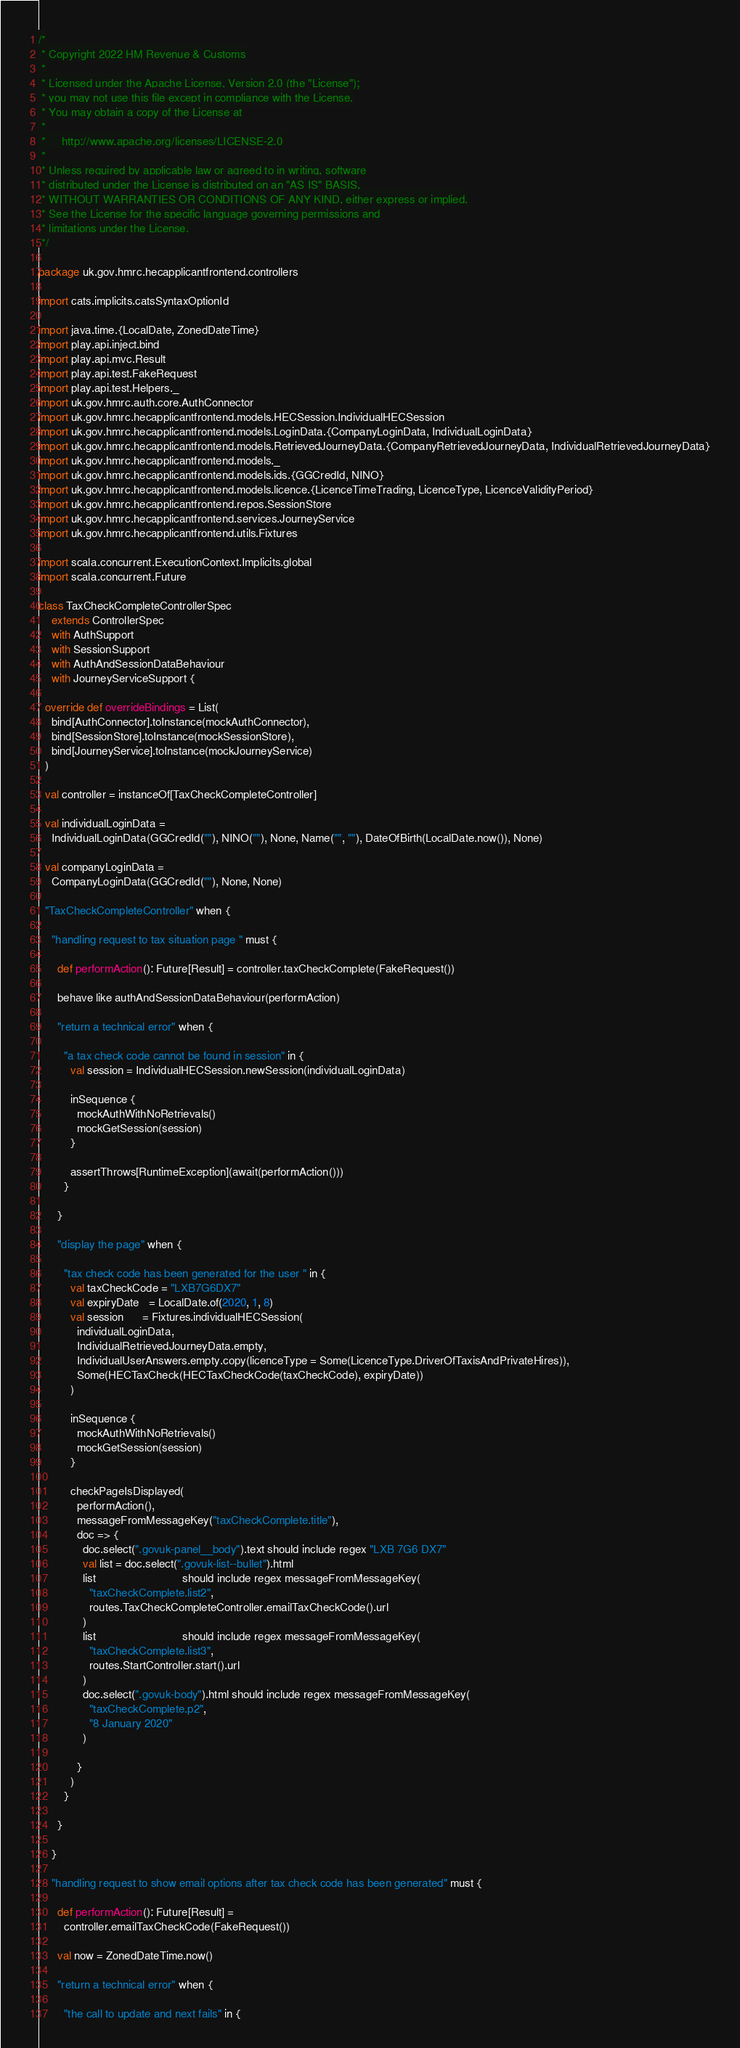<code> <loc_0><loc_0><loc_500><loc_500><_Scala_>/*
 * Copyright 2022 HM Revenue & Customs
 *
 * Licensed under the Apache License, Version 2.0 (the "License");
 * you may not use this file except in compliance with the License.
 * You may obtain a copy of the License at
 *
 *     http://www.apache.org/licenses/LICENSE-2.0
 *
 * Unless required by applicable law or agreed to in writing, software
 * distributed under the License is distributed on an "AS IS" BASIS,
 * WITHOUT WARRANTIES OR CONDITIONS OF ANY KIND, either express or implied.
 * See the License for the specific language governing permissions and
 * limitations under the License.
 */

package uk.gov.hmrc.hecapplicantfrontend.controllers

import cats.implicits.catsSyntaxOptionId

import java.time.{LocalDate, ZonedDateTime}
import play.api.inject.bind
import play.api.mvc.Result
import play.api.test.FakeRequest
import play.api.test.Helpers._
import uk.gov.hmrc.auth.core.AuthConnector
import uk.gov.hmrc.hecapplicantfrontend.models.HECSession.IndividualHECSession
import uk.gov.hmrc.hecapplicantfrontend.models.LoginData.{CompanyLoginData, IndividualLoginData}
import uk.gov.hmrc.hecapplicantfrontend.models.RetrievedJourneyData.{CompanyRetrievedJourneyData, IndividualRetrievedJourneyData}
import uk.gov.hmrc.hecapplicantfrontend.models._
import uk.gov.hmrc.hecapplicantfrontend.models.ids.{GGCredId, NINO}
import uk.gov.hmrc.hecapplicantfrontend.models.licence.{LicenceTimeTrading, LicenceType, LicenceValidityPeriod}
import uk.gov.hmrc.hecapplicantfrontend.repos.SessionStore
import uk.gov.hmrc.hecapplicantfrontend.services.JourneyService
import uk.gov.hmrc.hecapplicantfrontend.utils.Fixtures

import scala.concurrent.ExecutionContext.Implicits.global
import scala.concurrent.Future

class TaxCheckCompleteControllerSpec
    extends ControllerSpec
    with AuthSupport
    with SessionSupport
    with AuthAndSessionDataBehaviour
    with JourneyServiceSupport {

  override def overrideBindings = List(
    bind[AuthConnector].toInstance(mockAuthConnector),
    bind[SessionStore].toInstance(mockSessionStore),
    bind[JourneyService].toInstance(mockJourneyService)
  )

  val controller = instanceOf[TaxCheckCompleteController]

  val individualLoginData =
    IndividualLoginData(GGCredId(""), NINO(""), None, Name("", ""), DateOfBirth(LocalDate.now()), None)

  val companyLoginData =
    CompanyLoginData(GGCredId(""), None, None)

  "TaxCheckCompleteController" when {

    "handling request to tax situation page " must {

      def performAction(): Future[Result] = controller.taxCheckComplete(FakeRequest())

      behave like authAndSessionDataBehaviour(performAction)

      "return a technical error" when {

        "a tax check code cannot be found in session" in {
          val session = IndividualHECSession.newSession(individualLoginData)

          inSequence {
            mockAuthWithNoRetrievals()
            mockGetSession(session)
          }

          assertThrows[RuntimeException](await(performAction()))
        }

      }

      "display the page" when {

        "tax check code has been generated for the user " in {
          val taxCheckCode = "LXB7G6DX7"
          val expiryDate   = LocalDate.of(2020, 1, 8)
          val session      = Fixtures.individualHECSession(
            individualLoginData,
            IndividualRetrievedJourneyData.empty,
            IndividualUserAnswers.empty.copy(licenceType = Some(LicenceType.DriverOfTaxisAndPrivateHires)),
            Some(HECTaxCheck(HECTaxCheckCode(taxCheckCode), expiryDate))
          )

          inSequence {
            mockAuthWithNoRetrievals()
            mockGetSession(session)
          }

          checkPageIsDisplayed(
            performAction(),
            messageFromMessageKey("taxCheckComplete.title"),
            doc => {
              doc.select(".govuk-panel__body").text should include regex "LXB 7G6 DX7"
              val list = doc.select(".govuk-list--bullet").html
              list                           should include regex messageFromMessageKey(
                "taxCheckComplete.list2",
                routes.TaxCheckCompleteController.emailTaxCheckCode().url
              )
              list                           should include regex messageFromMessageKey(
                "taxCheckComplete.list3",
                routes.StartController.start().url
              )
              doc.select(".govuk-body").html should include regex messageFromMessageKey(
                "taxCheckComplete.p2",
                "8 January 2020"
              )

            }
          )
        }

      }

    }

    "handling request to show email options after tax check code has been generated" must {

      def performAction(): Future[Result] =
        controller.emailTaxCheckCode(FakeRequest())

      val now = ZonedDateTime.now()

      "return a technical error" when {

        "the call to update and next fails" in {</code> 